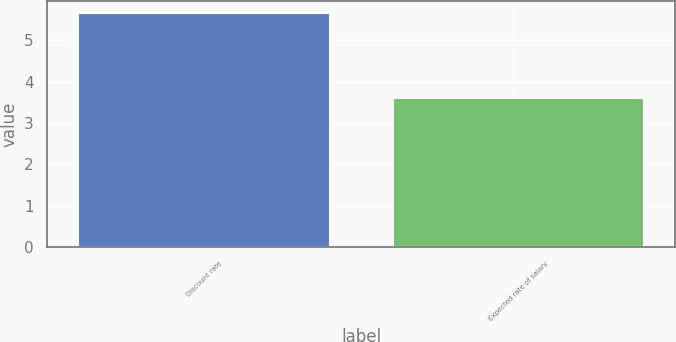Convert chart. <chart><loc_0><loc_0><loc_500><loc_500><bar_chart><fcel>Discount rate<fcel>Expected rate of salary<nl><fcel>5.65<fcel>3.6<nl></chart> 